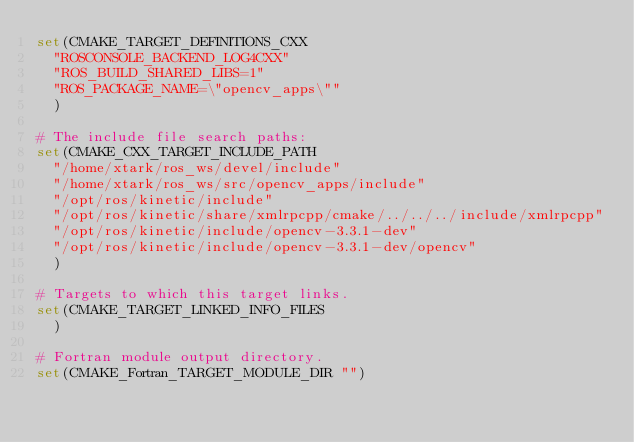<code> <loc_0><loc_0><loc_500><loc_500><_CMake_>set(CMAKE_TARGET_DEFINITIONS_CXX
  "ROSCONSOLE_BACKEND_LOG4CXX"
  "ROS_BUILD_SHARED_LIBS=1"
  "ROS_PACKAGE_NAME=\"opencv_apps\""
  )

# The include file search paths:
set(CMAKE_CXX_TARGET_INCLUDE_PATH
  "/home/xtark/ros_ws/devel/include"
  "/home/xtark/ros_ws/src/opencv_apps/include"
  "/opt/ros/kinetic/include"
  "/opt/ros/kinetic/share/xmlrpcpp/cmake/../../../include/xmlrpcpp"
  "/opt/ros/kinetic/include/opencv-3.3.1-dev"
  "/opt/ros/kinetic/include/opencv-3.3.1-dev/opencv"
  )

# Targets to which this target links.
set(CMAKE_TARGET_LINKED_INFO_FILES
  )

# Fortran module output directory.
set(CMAKE_Fortran_TARGET_MODULE_DIR "")
</code> 